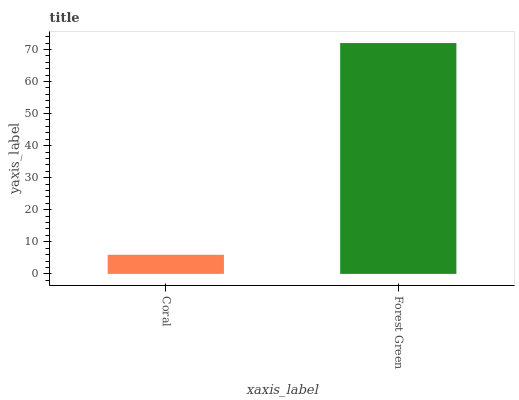Is Coral the minimum?
Answer yes or no. Yes. Is Forest Green the maximum?
Answer yes or no. Yes. Is Forest Green the minimum?
Answer yes or no. No. Is Forest Green greater than Coral?
Answer yes or no. Yes. Is Coral less than Forest Green?
Answer yes or no. Yes. Is Coral greater than Forest Green?
Answer yes or no. No. Is Forest Green less than Coral?
Answer yes or no. No. Is Forest Green the high median?
Answer yes or no. Yes. Is Coral the low median?
Answer yes or no. Yes. Is Coral the high median?
Answer yes or no. No. Is Forest Green the low median?
Answer yes or no. No. 